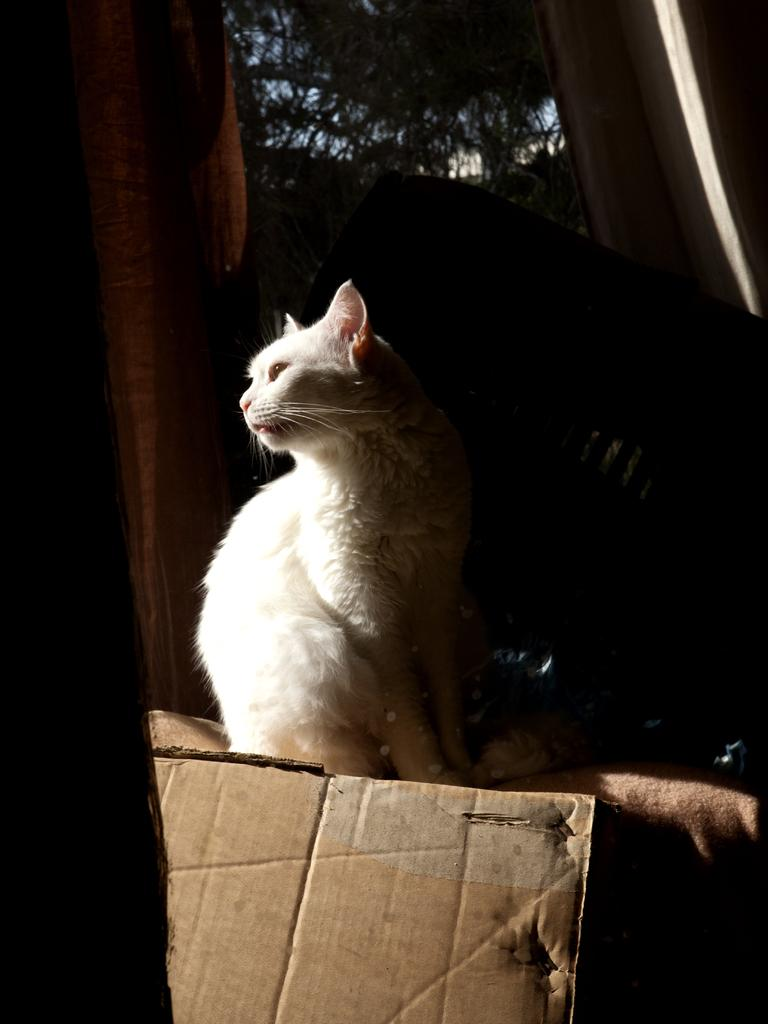What type of animal is in the image? There is a white cat in the image. What is the cat standing on? The cat is standing on cloth. What object is in front of the cat? There is a cardboard in front of the cat. What can be seen in the distance in the image? There is a tree visible in the background of the image. What type of hole can be seen in the advertisement in the image? There is no advertisement present in the image, and therefore no hole can be seen. 